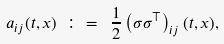Convert formula to latex. <formula><loc_0><loc_0><loc_500><loc_500>a _ { i j } ( t , x ) \ \colon = \ \frac { 1 } { 2 } \left ( \sigma \sigma ^ { \top } \right ) _ { i j } ( t , x ) ,</formula> 